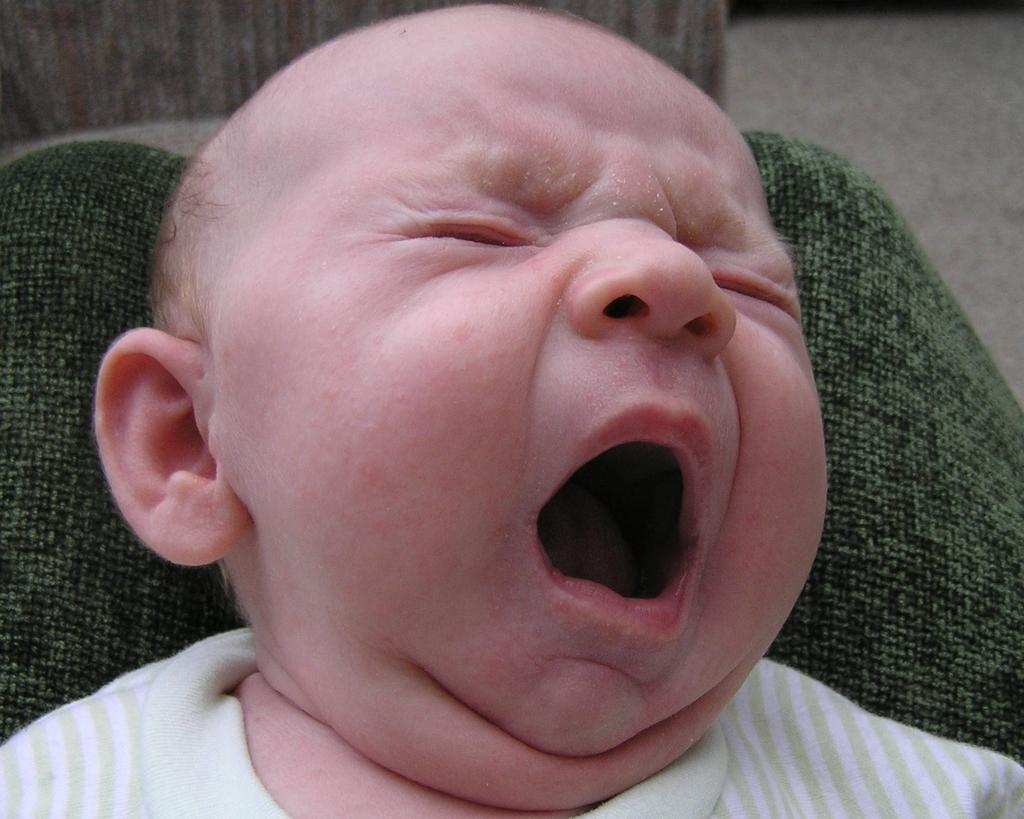What is the main subject of the image? The main subject of the image is a kid. What is the kid doing in the image? The kid is yawning. What class is the kid attending in the image? There is no indication of a class or any educational setting in the image. 